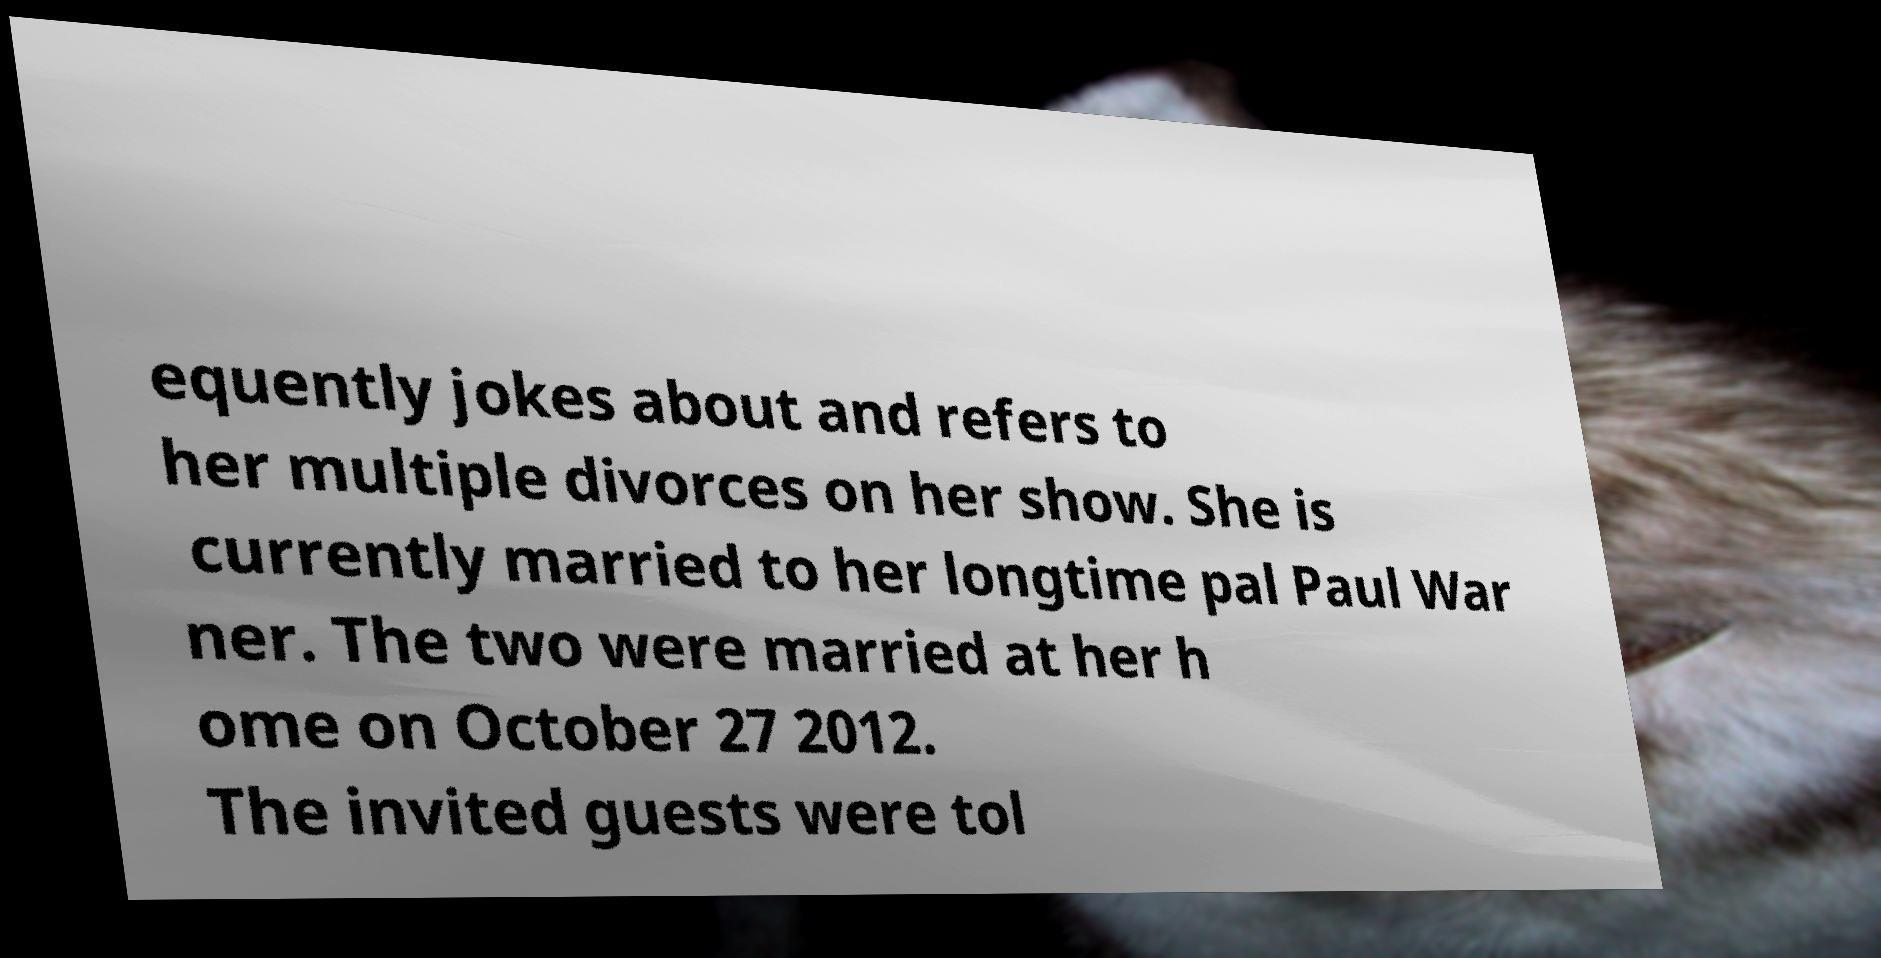Could you extract and type out the text from this image? equently jokes about and refers to her multiple divorces on her show. She is currently married to her longtime pal Paul War ner. The two were married at her h ome on October 27 2012. The invited guests were tol 